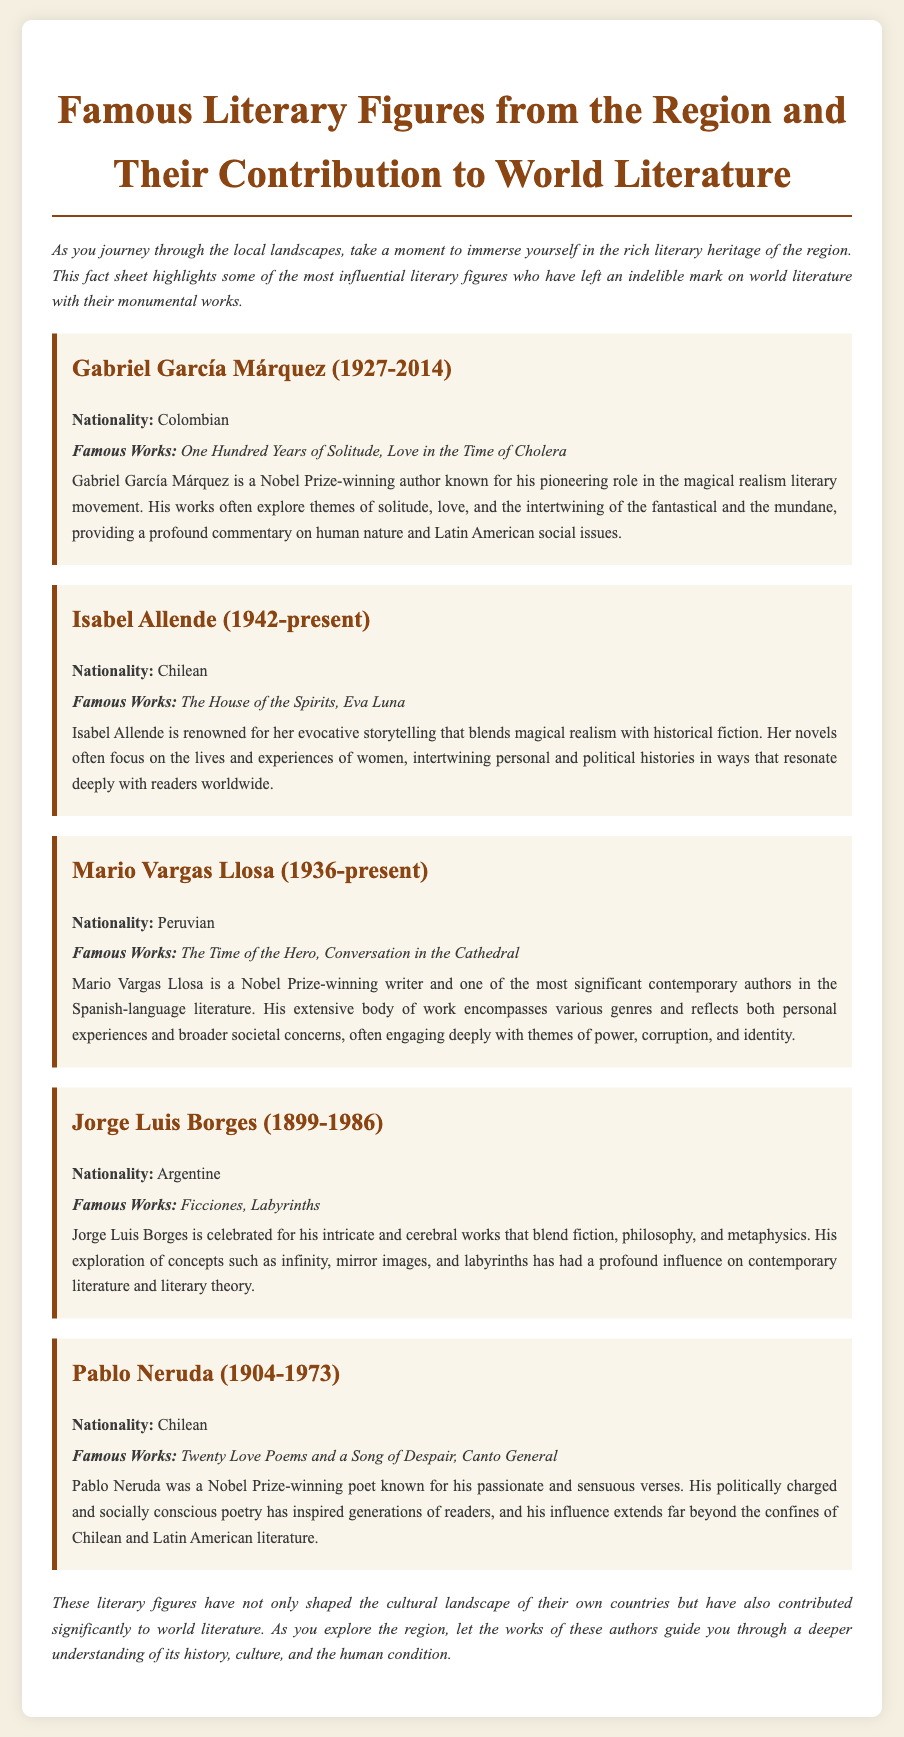What is the nationality of Gabriel García Márquez? The document specifies that Gabriel García Márquez is Colombian.
Answer: Colombian What are two famous works of Isabel Allende? The document lists "The House of the Spirits" and "Eva Luna" as famous works of Isabel Allende.
Answer: The House of the Spirits, Eva Luna Which literary movement is Gabriel García Márquez associated with? The document states that he is known for his role in the magical realism literary movement.
Answer: Magical realism Who is known for the poem "Twenty Love Poems and a Song of Despair"? The document indicates that Pablo Neruda is known for this work.
Answer: Pablo Neruda What common theme is present in Mario Vargas Llosa's works? The document discusses themes of power, corruption, and identity as common in Vargas Llosa's writing.
Answer: Power, corruption, identity Which author won a Nobel Prize and is also a poet? The document specifically mentions Pablo Neruda as a Nobel Prize-winning poet.
Answer: Pablo Neruda How many authors are featured in the document? The document features five authors.
Answer: Five What is the document's main focus? It highlights influential literary figures from the region and their contributions to world literature.
Answer: Influential literary figures and their contributions Which author’s works explore concepts such as infinity and labyrinths? The document attributes the exploration of these concepts to Jorge Luis Borges.
Answer: Jorge Luis Borges 